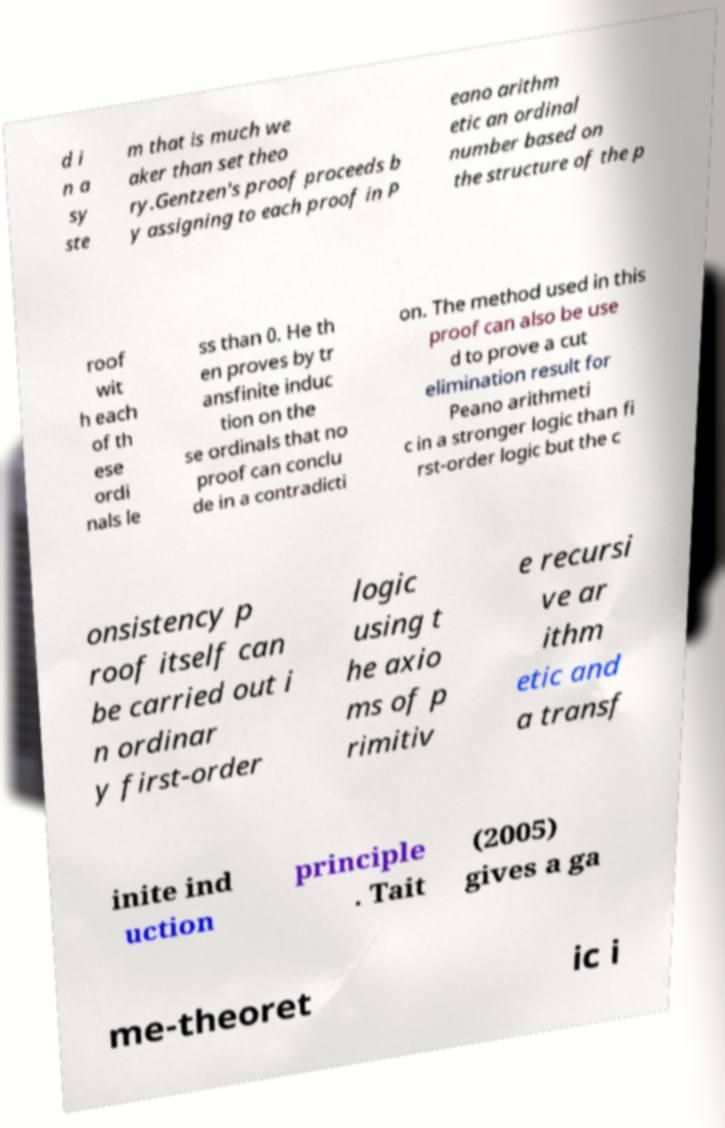Please read and relay the text visible in this image. What does it say? d i n a sy ste m that is much we aker than set theo ry.Gentzen's proof proceeds b y assigning to each proof in P eano arithm etic an ordinal number based on the structure of the p roof wit h each of th ese ordi nals le ss than 0. He th en proves by tr ansfinite induc tion on the se ordinals that no proof can conclu de in a contradicti on. The method used in this proof can also be use d to prove a cut elimination result for Peano arithmeti c in a stronger logic than fi rst-order logic but the c onsistency p roof itself can be carried out i n ordinar y first-order logic using t he axio ms of p rimitiv e recursi ve ar ithm etic and a transf inite ind uction principle . Tait (2005) gives a ga me-theoret ic i 